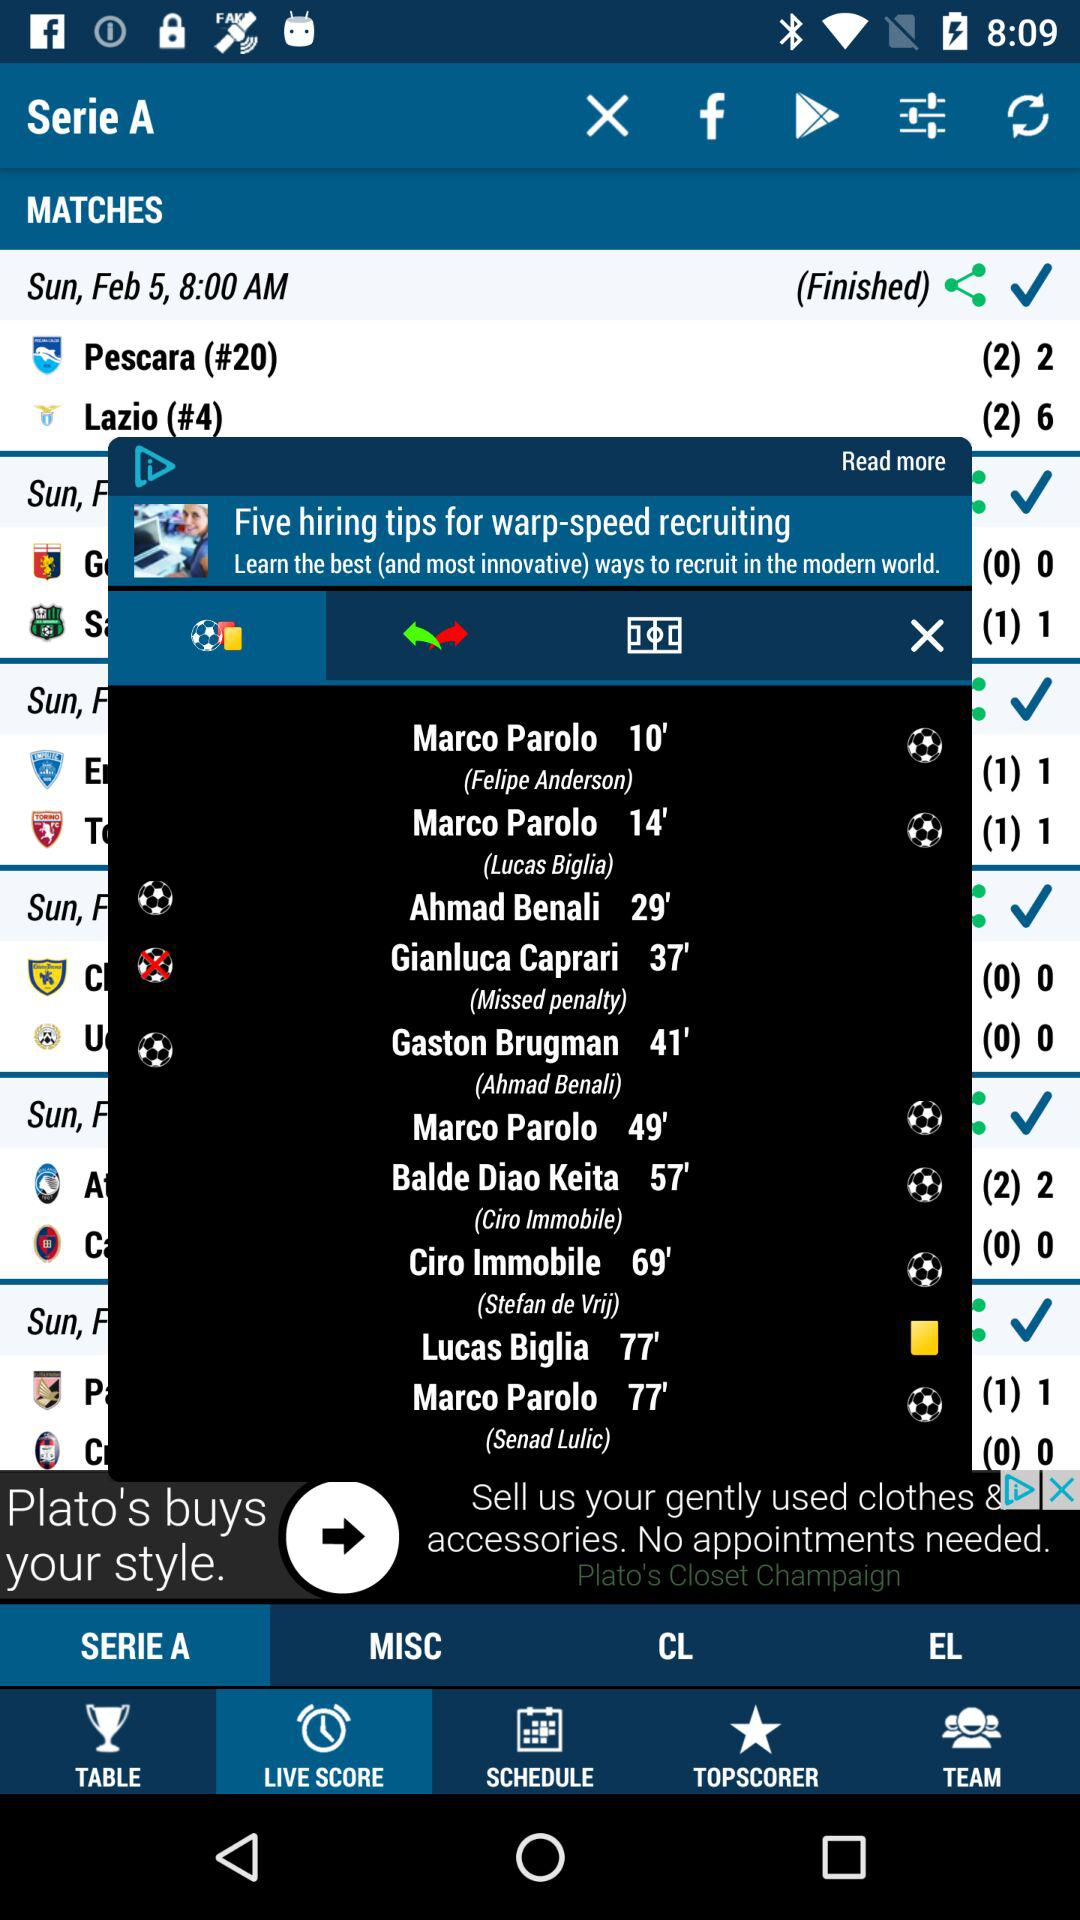Which tab is selected? The selected tab is "LIVE SCORE". 